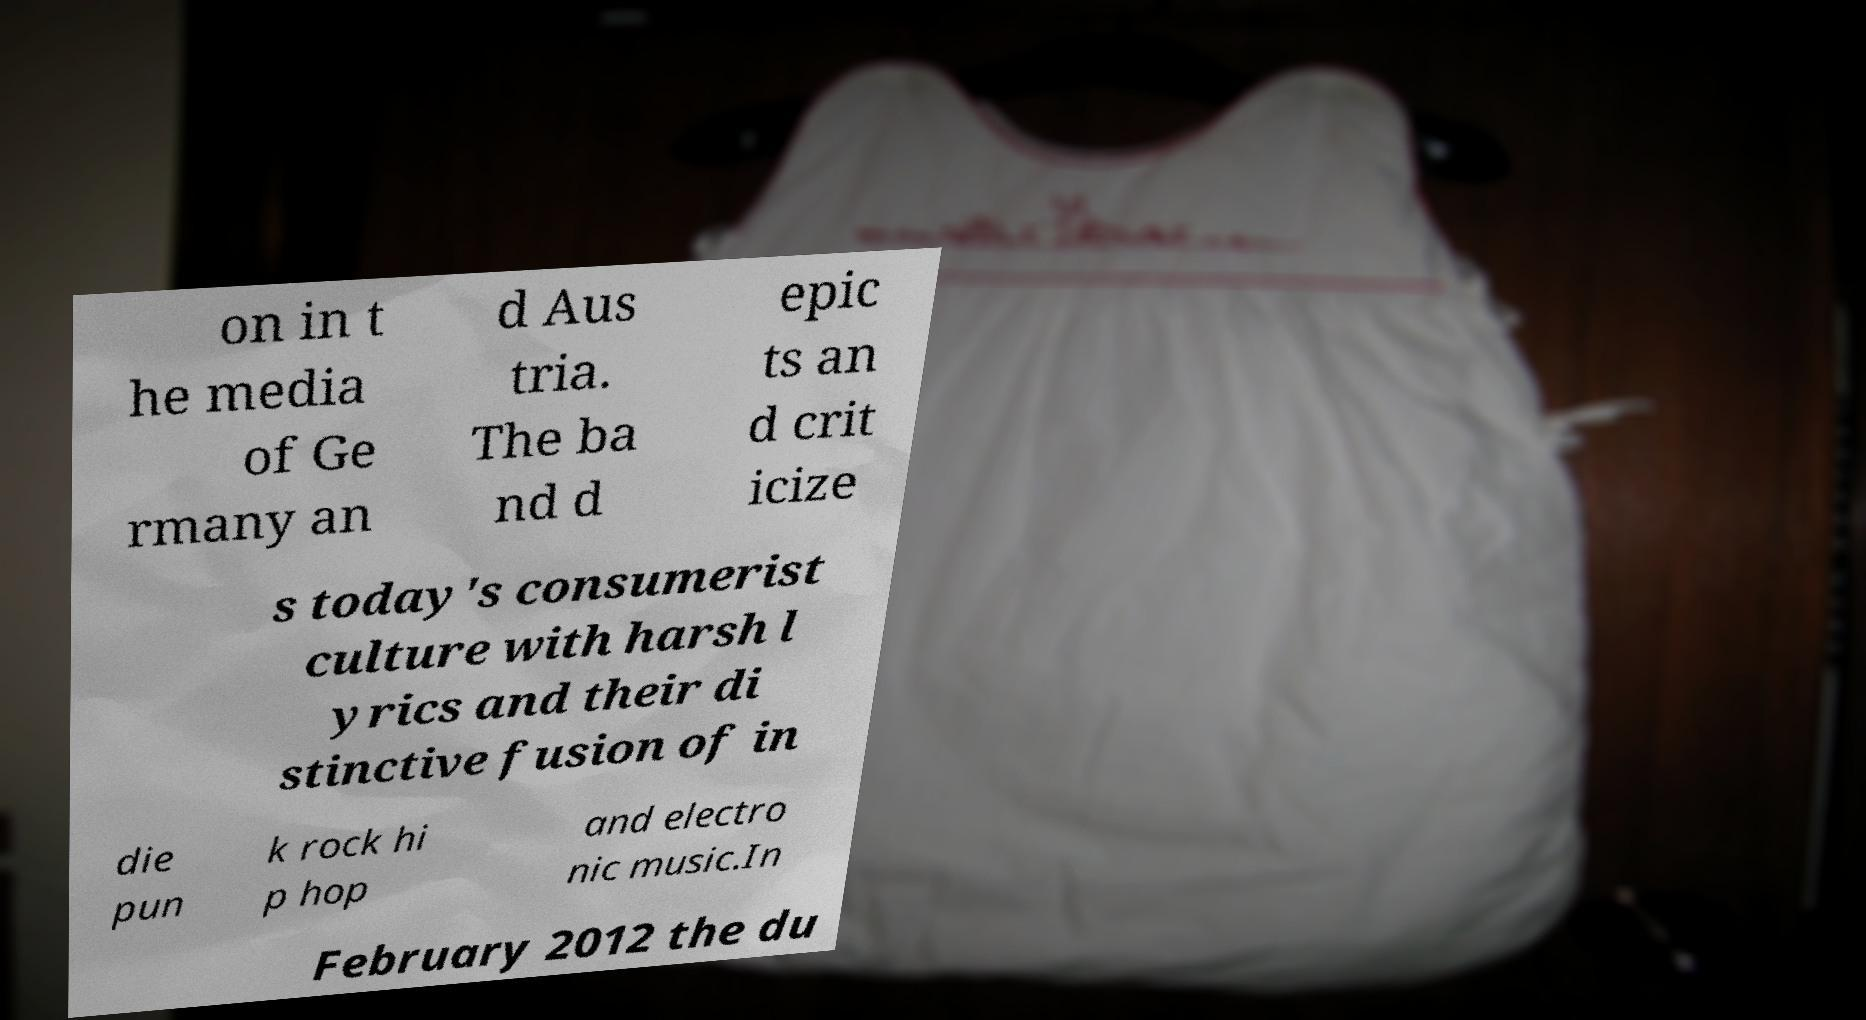What messages or text are displayed in this image? I need them in a readable, typed format. on in t he media of Ge rmany an d Aus tria. The ba nd d epic ts an d crit icize s today's consumerist culture with harsh l yrics and their di stinctive fusion of in die pun k rock hi p hop and electro nic music.In February 2012 the du 